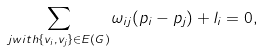Convert formula to latex. <formula><loc_0><loc_0><loc_500><loc_500>\sum _ { j w i t h \{ v _ { i } , v _ { j } \} \in E ( G ) } \omega _ { i j } ( p _ { i } - p _ { j } ) + l _ { i } = 0 ,</formula> 